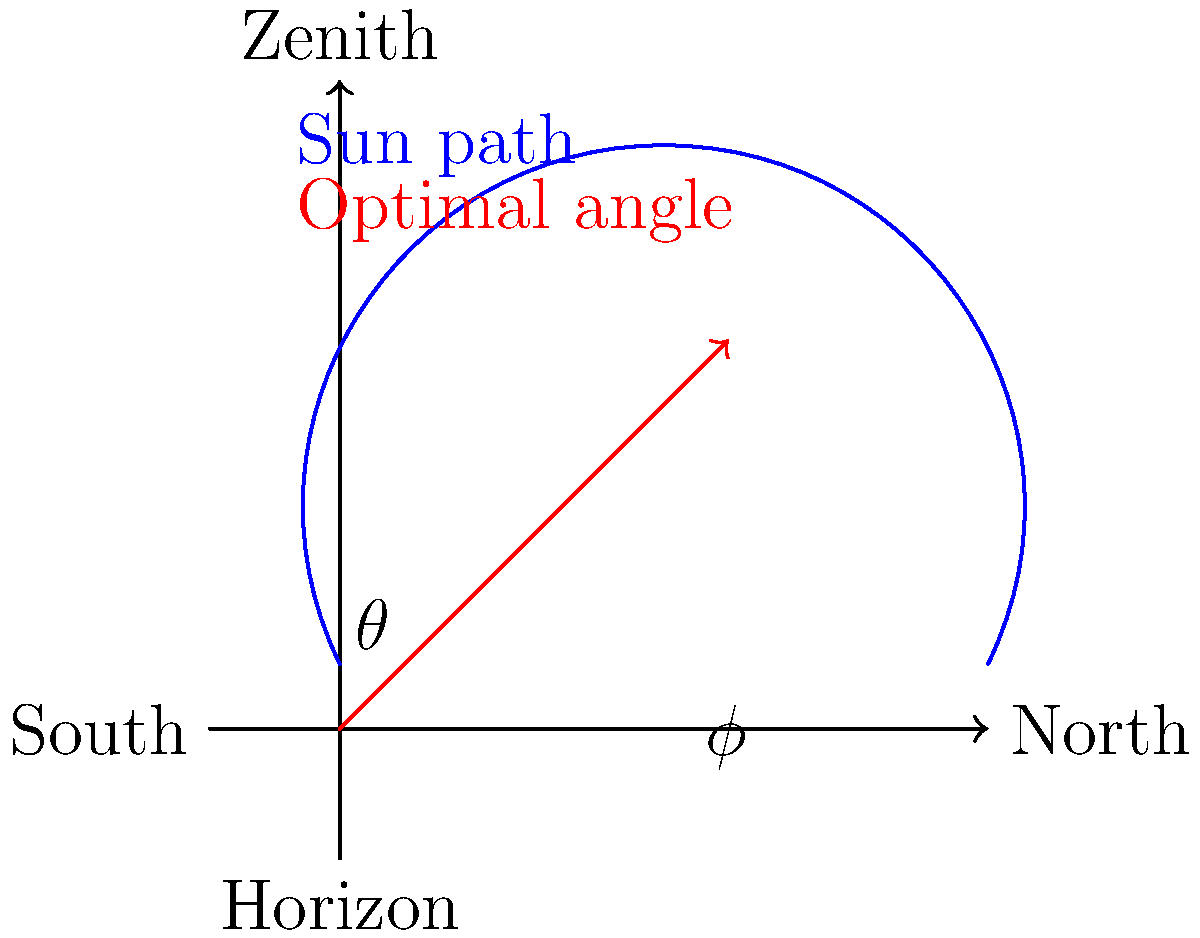Given a latitude $\phi = 40°$ and the sun path diagram shown above, calculate the optimal angle $\theta$ for solar panel installation to maximize energy capture throughout the year. To determine the optimal angle for solar panel installation, we can follow these steps:

1) The general rule for optimal solar panel tilt is to set the angle equal to the latitude of the location. This ensures that the panels are perpendicular to the sun's rays at solar noon during the equinoxes.

2) However, we need to make a slight adjustment to this rule. To optimize for year-round energy production, we typically subtract 10° from the latitude for locations above the Tropic of Cancer (23.5° N).

3) Given information:
   Latitude $\phi = 40°$

4) Calculate the optimal angle $\theta$:
   $\theta = \phi - 10°$
   $\theta = 40° - 10°$
   $\theta = 30°$

5) This 30° angle will provide a good balance between summer and winter solar energy capture. In the diagram, this is represented by the red arrow.

6) The blue curve represents the sun's path across the sky. The optimal panel angle allows the panels to capture maximum sunlight throughout the year, considering the sun's changing position.
Answer: $30°$ 